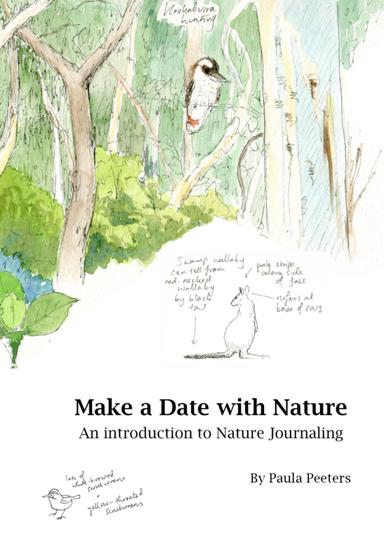What is the title of the book mentioned in the image? The title of the book shown in the image is "Make a Date with Nature: An Introduction to Nature Journaling," authored by Paula Peeters. This book offers an engaging exploration of nature journaling, a practice combining artwork and observations of the natural environment. 